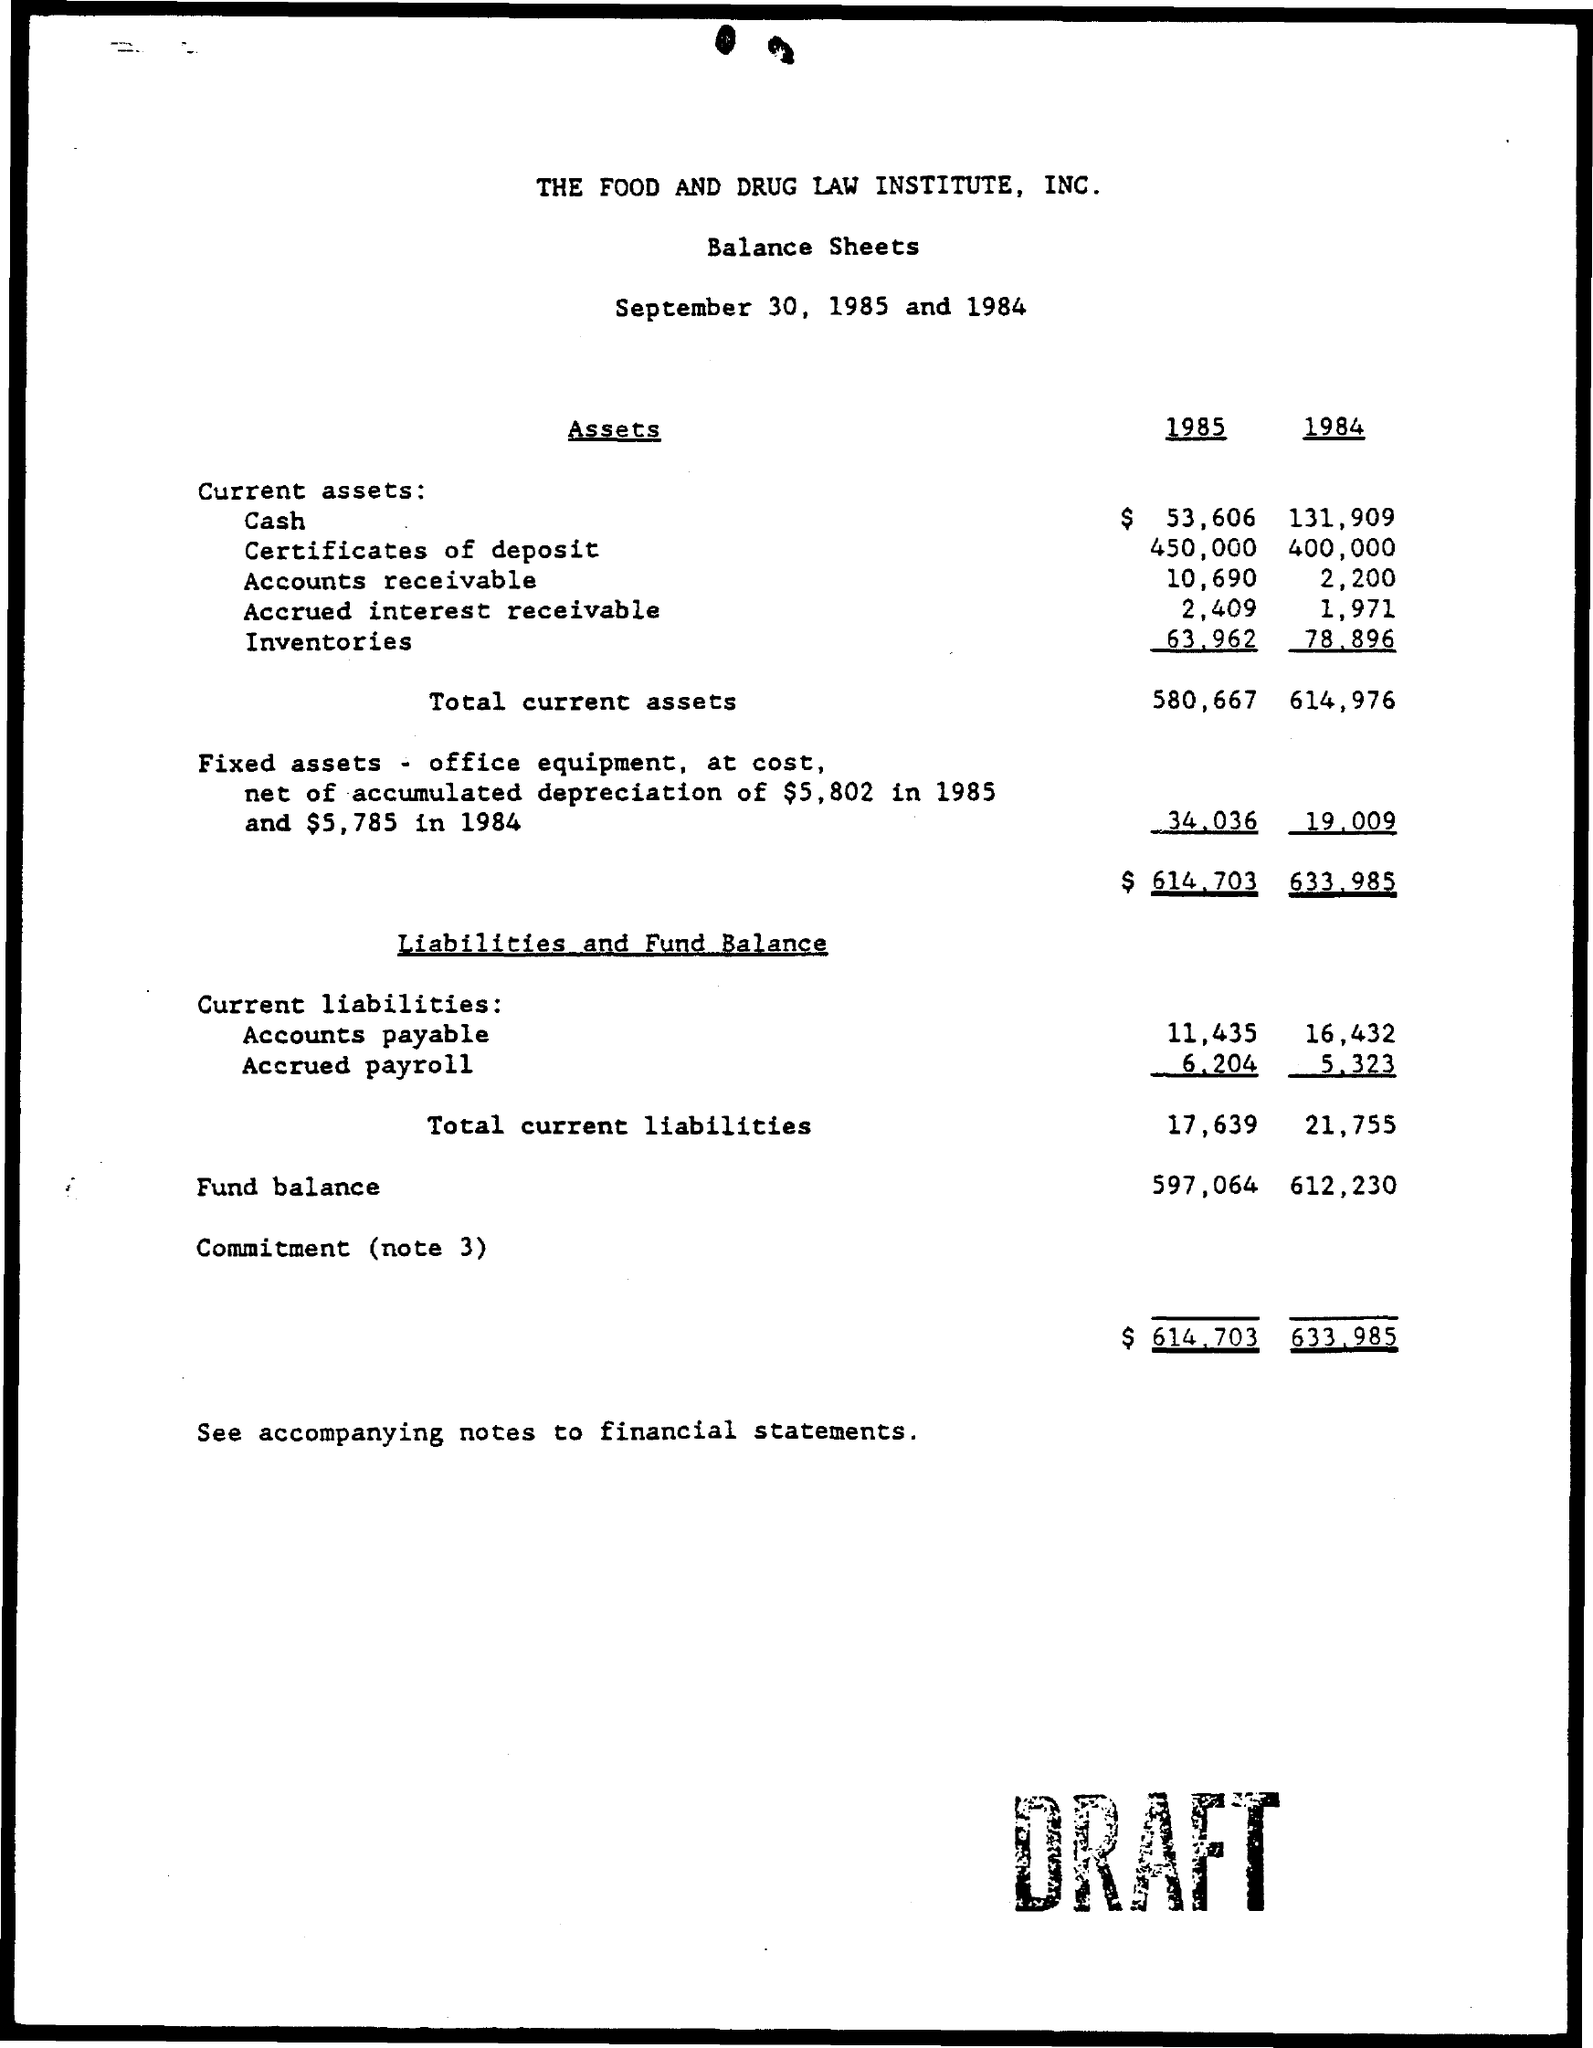What is the total current assets in the year 1985?
Offer a very short reply. 580,667. What is the total current liabilities in the year 1984?
Provide a short and direct response. 21,755. 